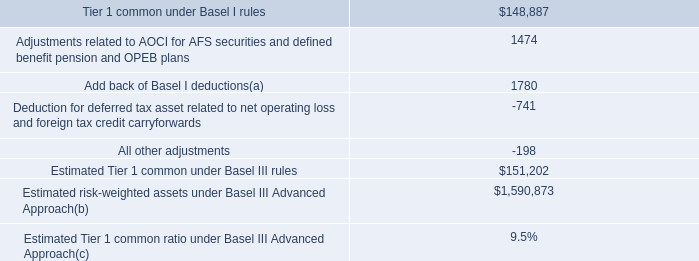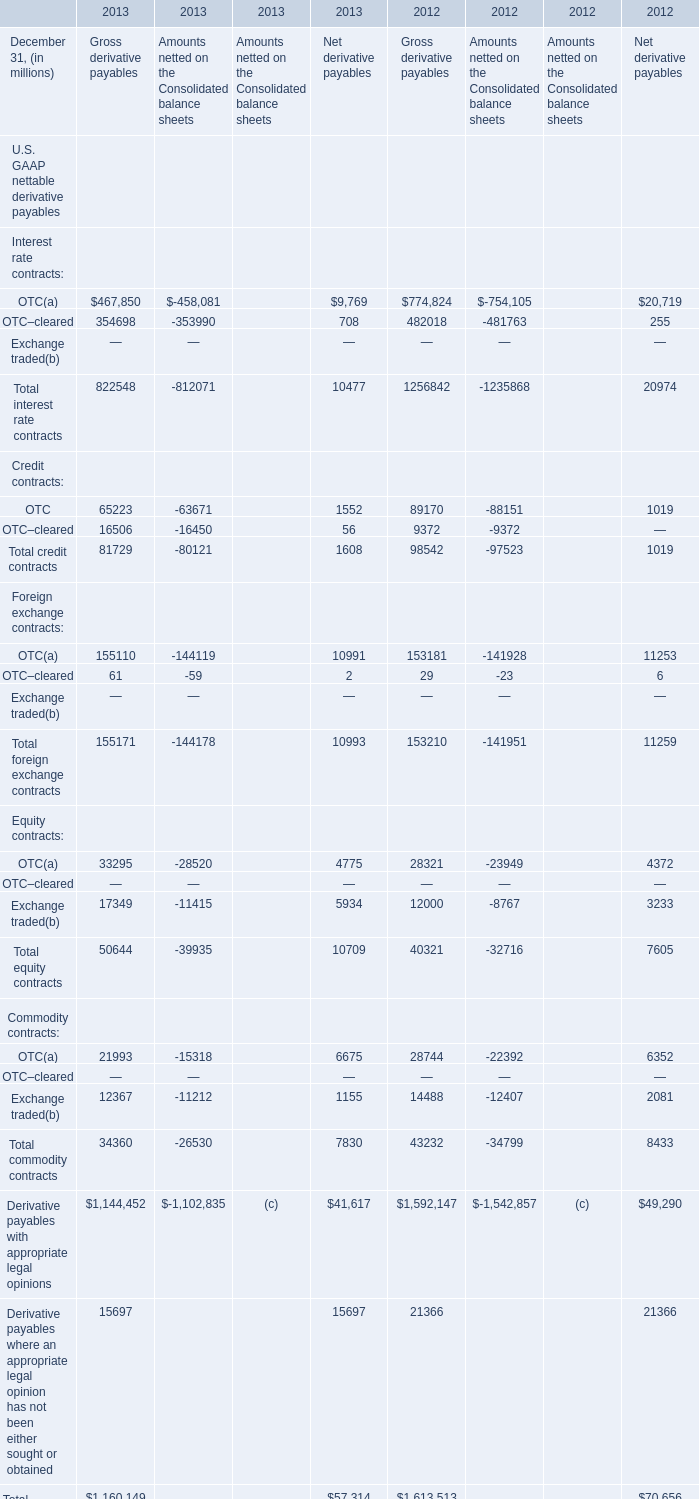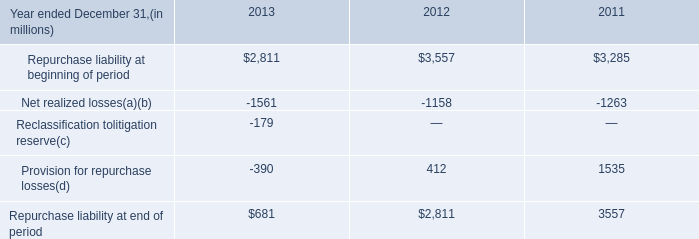Which year is Gross derivative payables of Credit contracts OTC the most? 
Answer: 2013. what would the estimated minimum amount of tier 1 common equity be under the minimum basel 6.5% ( 6.5 % ) standard ? ( billions ) 
Computations: ((151202 / 9.4%) * 6.5%)
Answer: 104554.57447. 